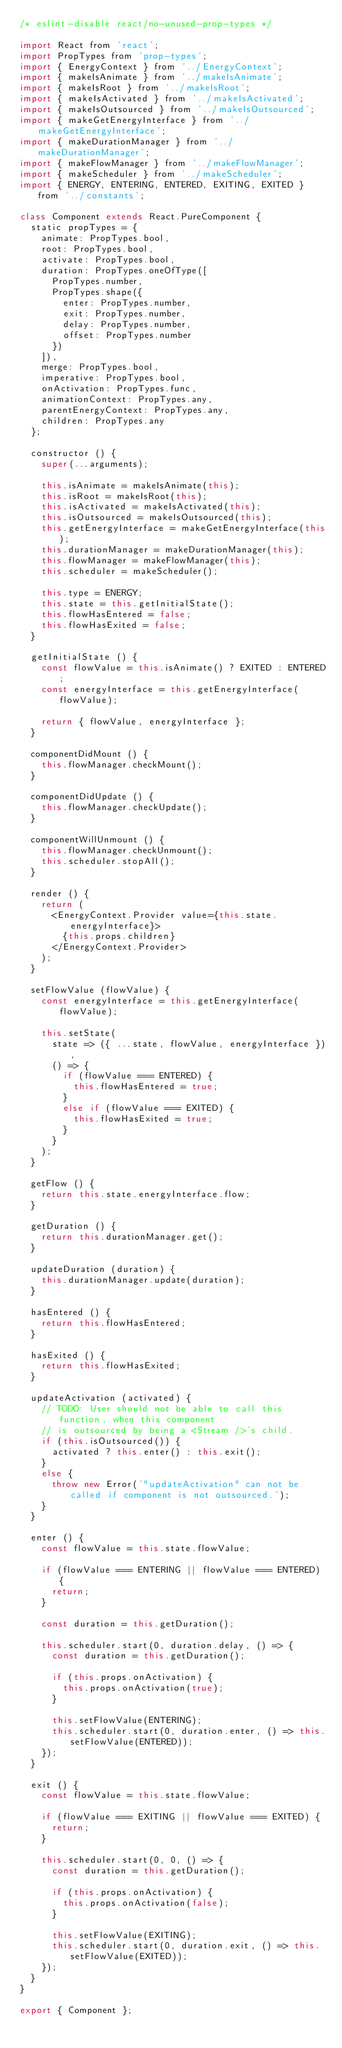Convert code to text. <code><loc_0><loc_0><loc_500><loc_500><_JavaScript_>/* eslint-disable react/no-unused-prop-types */

import React from 'react';
import PropTypes from 'prop-types';
import { EnergyContext } from '../EnergyContext';
import { makeIsAnimate } from '../makeIsAnimate';
import { makeIsRoot } from '../makeIsRoot';
import { makeIsActivated } from '../makeIsActivated';
import { makeIsOutsourced } from '../makeIsOutsourced';
import { makeGetEnergyInterface } from '../makeGetEnergyInterface';
import { makeDurationManager } from '../makeDurationManager';
import { makeFlowManager } from '../makeFlowManager';
import { makeScheduler } from '../makeScheduler';
import { ENERGY, ENTERING, ENTERED, EXITING, EXITED } from '../constants';

class Component extends React.PureComponent {
  static propTypes = {
    animate: PropTypes.bool,
    root: PropTypes.bool,
    activate: PropTypes.bool,
    duration: PropTypes.oneOfType([
      PropTypes.number,
      PropTypes.shape({
        enter: PropTypes.number,
        exit: PropTypes.number,
        delay: PropTypes.number,
        offset: PropTypes.number
      })
    ]),
    merge: PropTypes.bool,
    imperative: PropTypes.bool,
    onActivation: PropTypes.func,
    animationContext: PropTypes.any,
    parentEnergyContext: PropTypes.any,
    children: PropTypes.any
  };

  constructor () {
    super(...arguments);

    this.isAnimate = makeIsAnimate(this);
    this.isRoot = makeIsRoot(this);
    this.isActivated = makeIsActivated(this);
    this.isOutsourced = makeIsOutsourced(this);
    this.getEnergyInterface = makeGetEnergyInterface(this);
    this.durationManager = makeDurationManager(this);
    this.flowManager = makeFlowManager(this);
    this.scheduler = makeScheduler();

    this.type = ENERGY;
    this.state = this.getInitialState();
    this.flowHasEntered = false;
    this.flowHasExited = false;
  }

  getInitialState () {
    const flowValue = this.isAnimate() ? EXITED : ENTERED;
    const energyInterface = this.getEnergyInterface(flowValue);

    return { flowValue, energyInterface };
  }

  componentDidMount () {
    this.flowManager.checkMount();
  }

  componentDidUpdate () {
    this.flowManager.checkUpdate();
  }

  componentWillUnmount () {
    this.flowManager.checkUnmount();
    this.scheduler.stopAll();
  }

  render () {
    return (
      <EnergyContext.Provider value={this.state.energyInterface}>
        {this.props.children}
      </EnergyContext.Provider>
    );
  }

  setFlowValue (flowValue) {
    const energyInterface = this.getEnergyInterface(flowValue);

    this.setState(
      state => ({ ...state, flowValue, energyInterface }),
      () => {
        if (flowValue === ENTERED) {
          this.flowHasEntered = true;
        }
        else if (flowValue === EXITED) {
          this.flowHasExited = true;
        }
      }
    );
  }

  getFlow () {
    return this.state.energyInterface.flow;
  }

  getDuration () {
    return this.durationManager.get();
  }

  updateDuration (duration) {
    this.durationManager.update(duration);
  }

  hasEntered () {
    return this.flowHasEntered;
  }

  hasExited () {
    return this.flowHasExited;
  }

  updateActivation (activated) {
    // TODO: User should not be able to call this function, when this component
    // is outsourced by being a <Stream />'s child.
    if (this.isOutsourced()) {
      activated ? this.enter() : this.exit();
    }
    else {
      throw new Error('"updateActivation" can not be called if component is not outsourced.');
    }
  }

  enter () {
    const flowValue = this.state.flowValue;

    if (flowValue === ENTERING || flowValue === ENTERED) {
      return;
    }

    const duration = this.getDuration();

    this.scheduler.start(0, duration.delay, () => {
      const duration = this.getDuration();

      if (this.props.onActivation) {
        this.props.onActivation(true);
      }

      this.setFlowValue(ENTERING);
      this.scheduler.start(0, duration.enter, () => this.setFlowValue(ENTERED));
    });
  }

  exit () {
    const flowValue = this.state.flowValue;

    if (flowValue === EXITING || flowValue === EXITED) {
      return;
    }

    this.scheduler.start(0, 0, () => {
      const duration = this.getDuration();

      if (this.props.onActivation) {
        this.props.onActivation(false);
      }

      this.setFlowValue(EXITING);
      this.scheduler.start(0, duration.exit, () => this.setFlowValue(EXITED));
    });
  }
}

export { Component };
</code> 